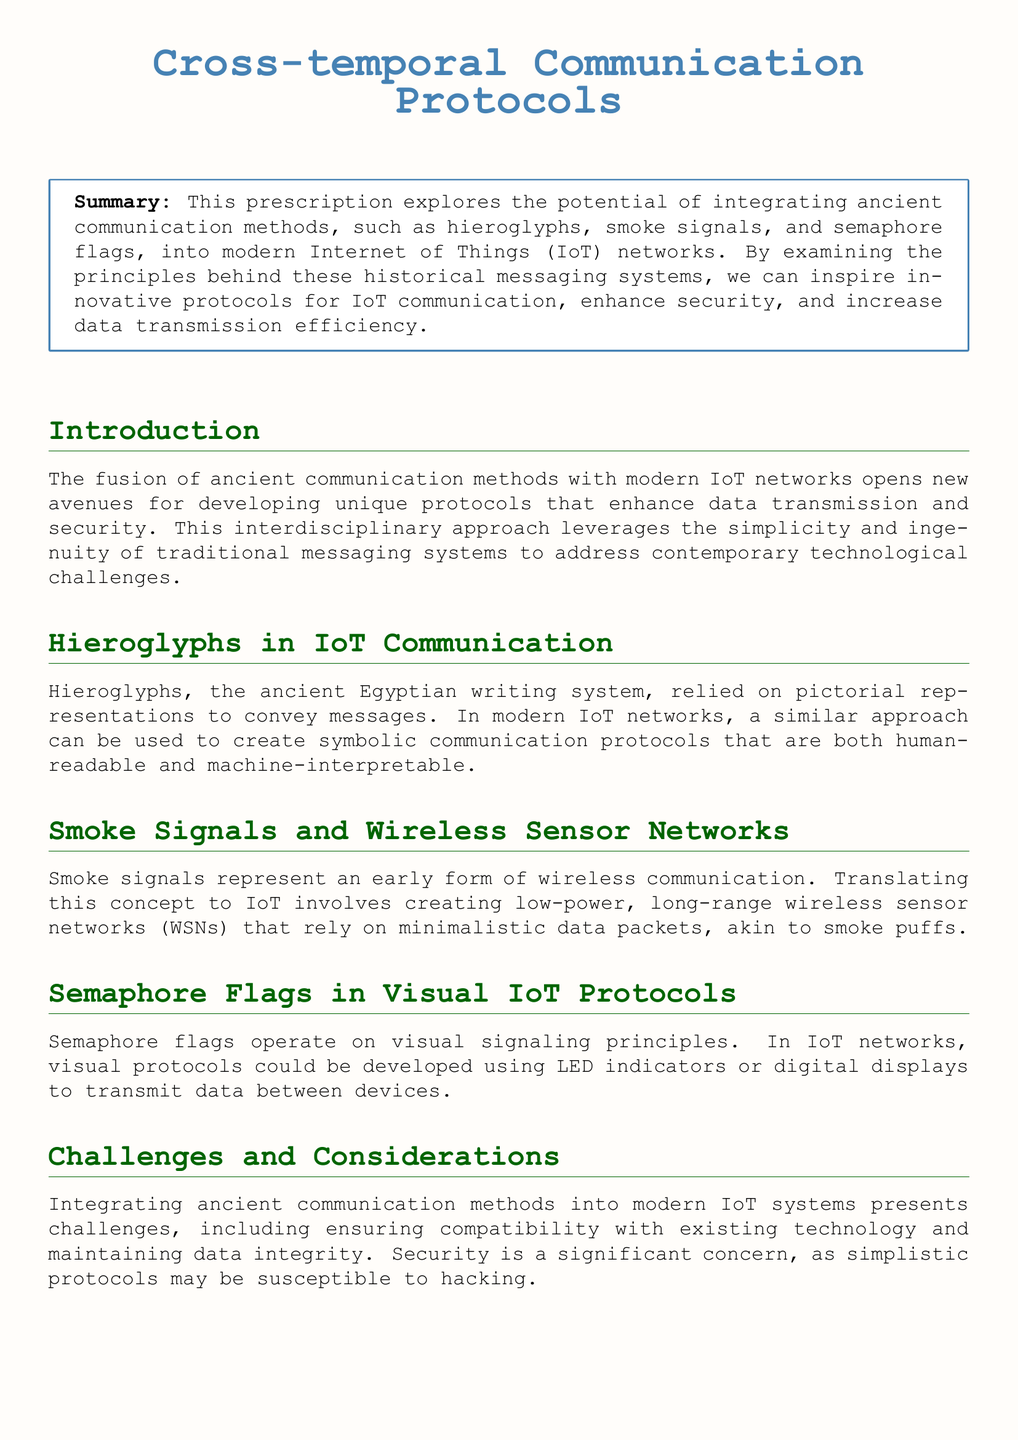What is the title of the document? The title is located at the center of the document and is prominently displayed.
Answer: Cross-temporal Communication Protocols What ancient communication method is explored for IoT communication? The document addresses various ancient methods, one of which is hieroglyphs mentioned in a specific section.
Answer: Hieroglyphs What modern technology is being integrated with ancient communication methods? The document explicitly mentions the technology being addressed in the context of the ancient methods explored.
Answer: IoT networks What challenge is specifically mentioned regarding the integration of ancient methods? A key concern highlighted in the Challenges section addresses the compatibility with existing technology.
Answer: Compatibility Which ancient communication system relied on visual signaling? The document describes the relevance of this visual method in a specific section.
Answer: Semaphore flags How many examples are provided in the Further Reading section? The number of examples mentioned can be retrieved from the list of references in that section.
Answer: Three What is a similarity drawn between smoke signals and IoT? The document draws a parallel between ancient and modern methods of communication in terms of data transmission.
Answer: Low-power, long-range wireless sensor networks What is the color used for the title in the document? The title's color is defined at the beginning of the document, indicating its aesthetic choice.
Answer: Title Color What type of document is this? The classification of the document can be inferred from its structure and purpose, as described in the introductory section.
Answer: Prescription 